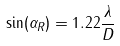<formula> <loc_0><loc_0><loc_500><loc_500>\sin ( \alpha _ { R } ) = 1 . 2 2 \frac { \lambda } { D }</formula> 